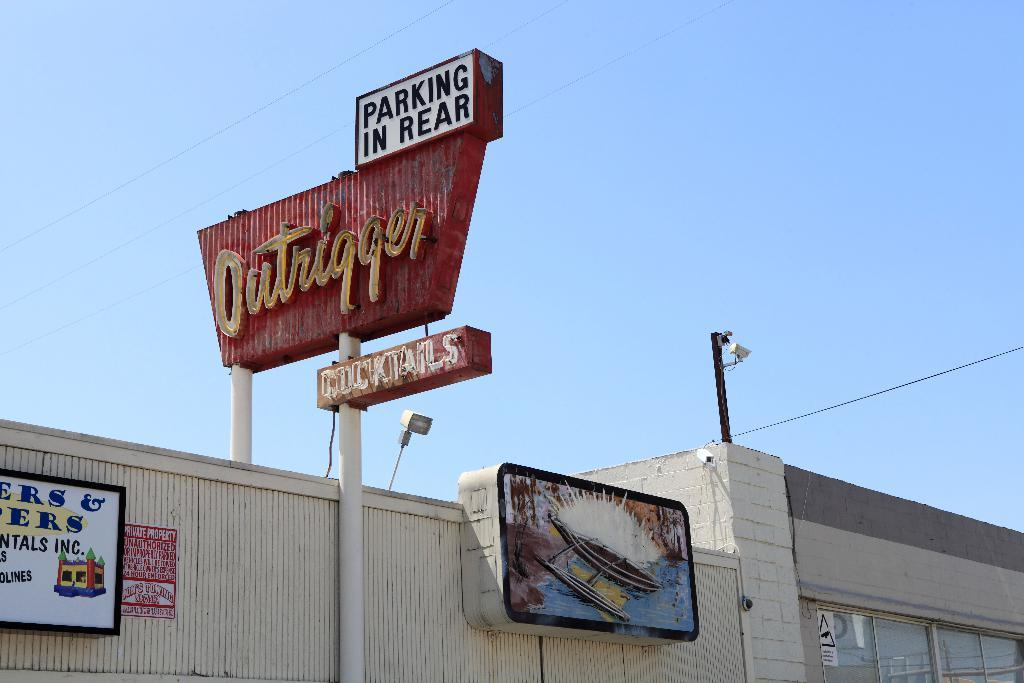<image>
Write a terse but informative summary of the picture. A large red sign identifies a building as a cocktail bar called Outrigger. 